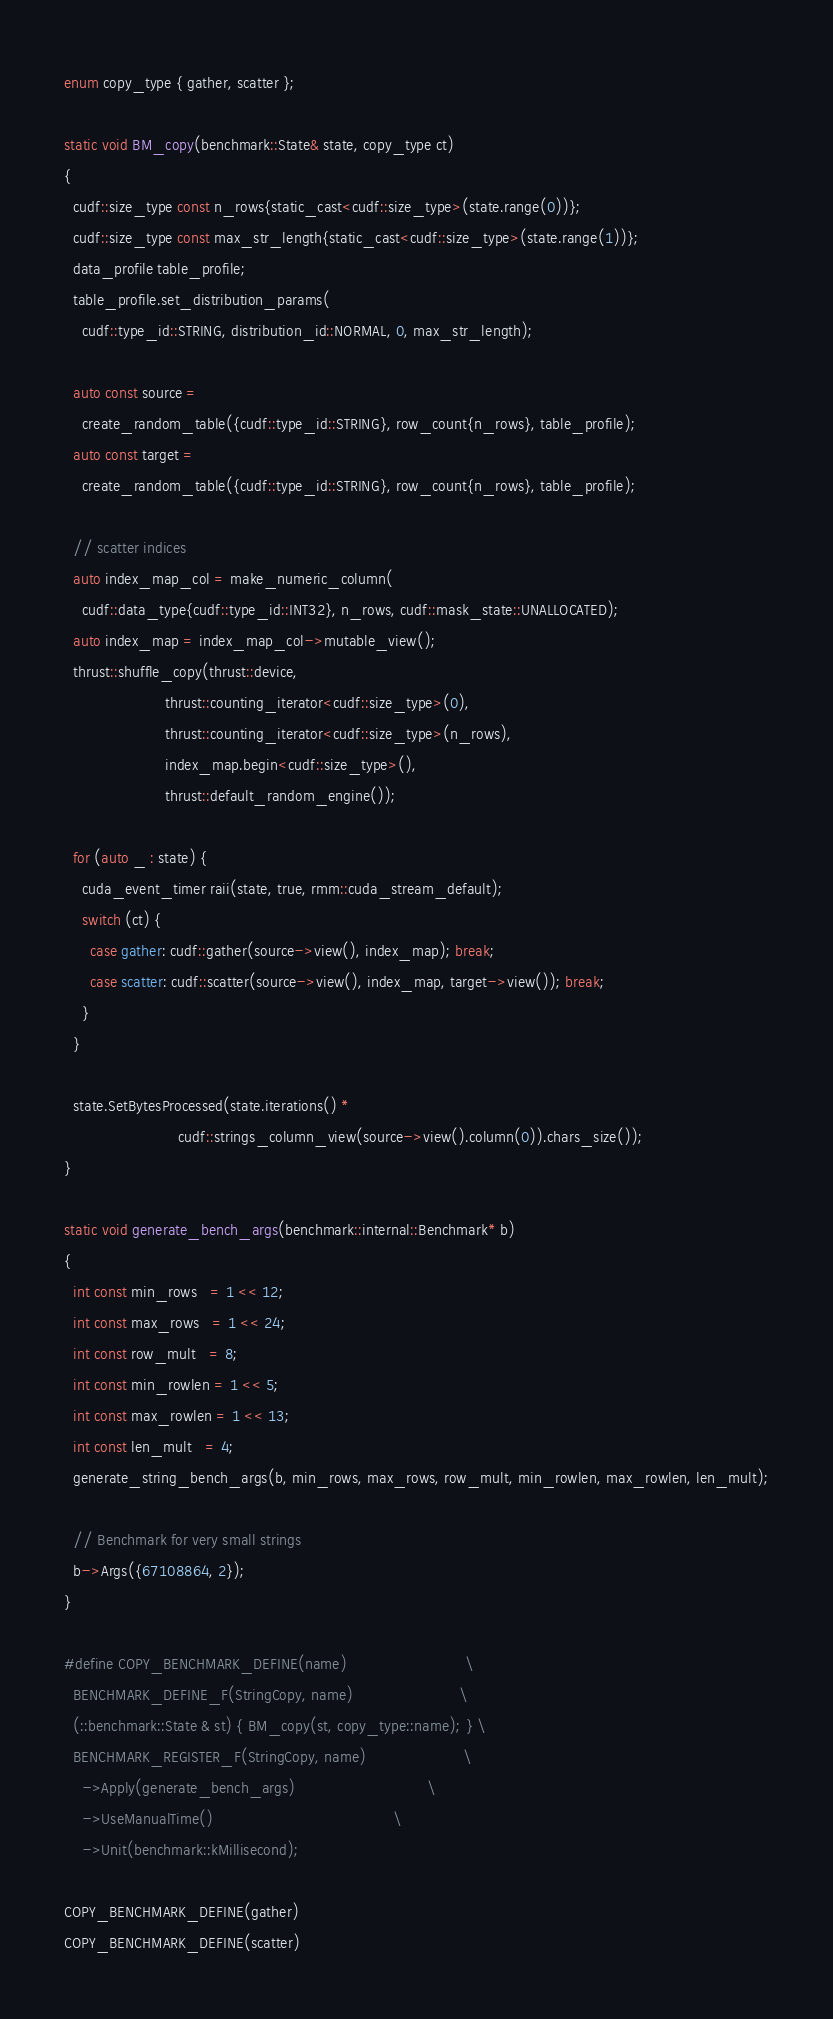<code> <loc_0><loc_0><loc_500><loc_500><_Cuda_>
enum copy_type { gather, scatter };

static void BM_copy(benchmark::State& state, copy_type ct)
{
  cudf::size_type const n_rows{static_cast<cudf::size_type>(state.range(0))};
  cudf::size_type const max_str_length{static_cast<cudf::size_type>(state.range(1))};
  data_profile table_profile;
  table_profile.set_distribution_params(
    cudf::type_id::STRING, distribution_id::NORMAL, 0, max_str_length);

  auto const source =
    create_random_table({cudf::type_id::STRING}, row_count{n_rows}, table_profile);
  auto const target =
    create_random_table({cudf::type_id::STRING}, row_count{n_rows}, table_profile);

  // scatter indices
  auto index_map_col = make_numeric_column(
    cudf::data_type{cudf::type_id::INT32}, n_rows, cudf::mask_state::UNALLOCATED);
  auto index_map = index_map_col->mutable_view();
  thrust::shuffle_copy(thrust::device,
                       thrust::counting_iterator<cudf::size_type>(0),
                       thrust::counting_iterator<cudf::size_type>(n_rows),
                       index_map.begin<cudf::size_type>(),
                       thrust::default_random_engine());

  for (auto _ : state) {
    cuda_event_timer raii(state, true, rmm::cuda_stream_default);
    switch (ct) {
      case gather: cudf::gather(source->view(), index_map); break;
      case scatter: cudf::scatter(source->view(), index_map, target->view()); break;
    }
  }

  state.SetBytesProcessed(state.iterations() *
                          cudf::strings_column_view(source->view().column(0)).chars_size());
}

static void generate_bench_args(benchmark::internal::Benchmark* b)
{
  int const min_rows   = 1 << 12;
  int const max_rows   = 1 << 24;
  int const row_mult   = 8;
  int const min_rowlen = 1 << 5;
  int const max_rowlen = 1 << 13;
  int const len_mult   = 4;
  generate_string_bench_args(b, min_rows, max_rows, row_mult, min_rowlen, max_rowlen, len_mult);

  // Benchmark for very small strings
  b->Args({67108864, 2});
}

#define COPY_BENCHMARK_DEFINE(name)                           \
  BENCHMARK_DEFINE_F(StringCopy, name)                        \
  (::benchmark::State & st) { BM_copy(st, copy_type::name); } \
  BENCHMARK_REGISTER_F(StringCopy, name)                      \
    ->Apply(generate_bench_args)                              \
    ->UseManualTime()                                         \
    ->Unit(benchmark::kMillisecond);

COPY_BENCHMARK_DEFINE(gather)
COPY_BENCHMARK_DEFINE(scatter)
</code> 